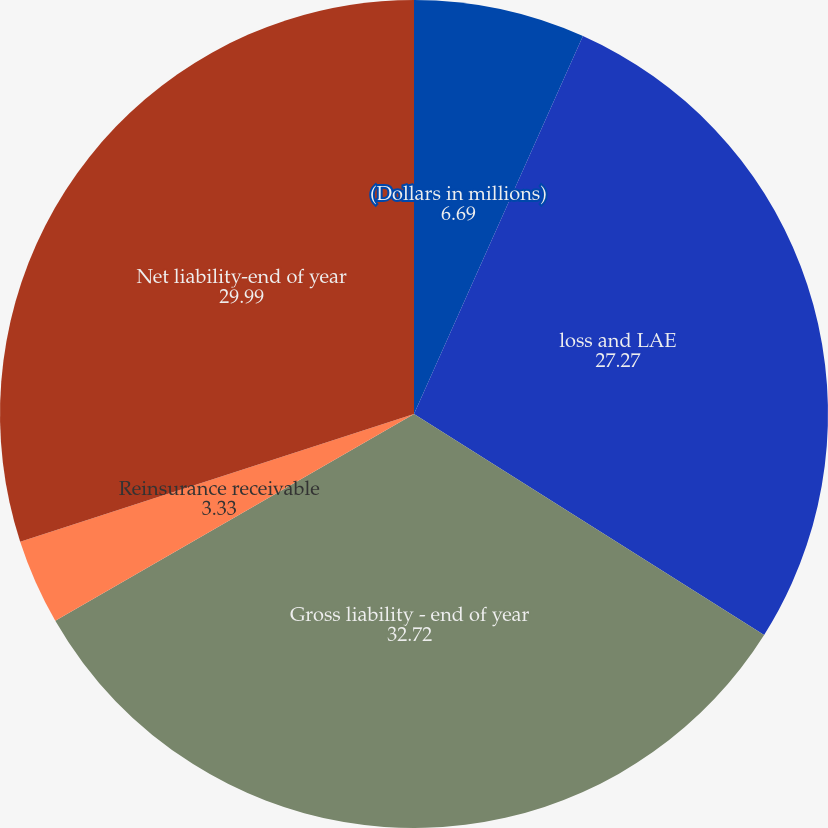Convert chart to OTSL. <chart><loc_0><loc_0><loc_500><loc_500><pie_chart><fcel>(Dollars in millions)<fcel>loss and LAE<fcel>Gross liability - end of year<fcel>Reinsurance receivable<fcel>Net liability-end of year<nl><fcel>6.69%<fcel>27.27%<fcel>32.72%<fcel>3.33%<fcel>29.99%<nl></chart> 